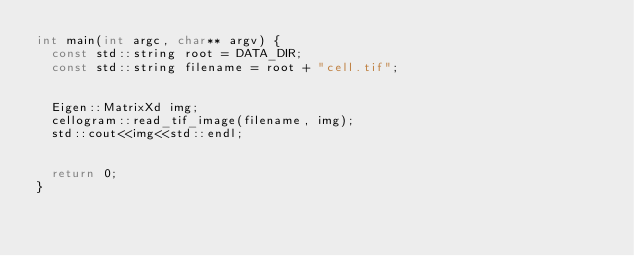<code> <loc_0><loc_0><loc_500><loc_500><_C++_>int main(int argc, char** argv) {
	const std::string root = DATA_DIR;
	const std::string filename = root + "cell.tif";


	Eigen::MatrixXd img;
	cellogram::read_tif_image(filename, img);
	std::cout<<img<<std::endl;


	return 0;
}
</code> 